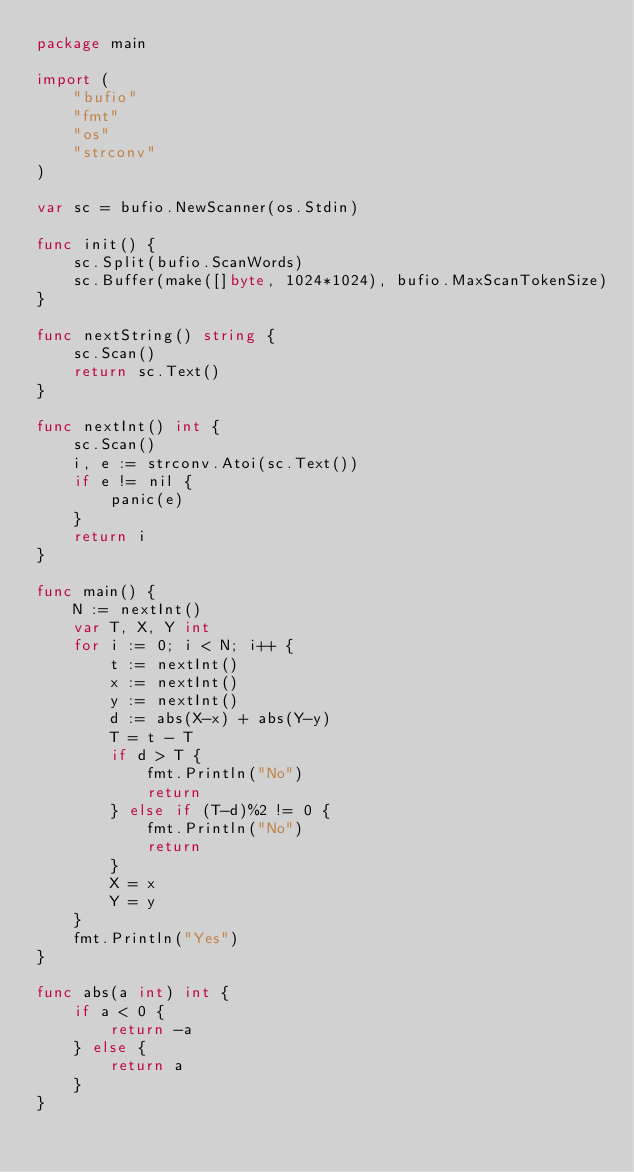<code> <loc_0><loc_0><loc_500><loc_500><_Go_>package main

import (
	"bufio"
	"fmt"
	"os"
	"strconv"
)

var sc = bufio.NewScanner(os.Stdin)

func init() {
	sc.Split(bufio.ScanWords)
	sc.Buffer(make([]byte, 1024*1024), bufio.MaxScanTokenSize)
}

func nextString() string {
	sc.Scan()
	return sc.Text()
}

func nextInt() int {
	sc.Scan()
	i, e := strconv.Atoi(sc.Text())
	if e != nil {
		panic(e)
	}
	return i
}

func main() {
	N := nextInt()
	var T, X, Y int
	for i := 0; i < N; i++ {
		t := nextInt()
		x := nextInt()
		y := nextInt()
		d := abs(X-x) + abs(Y-y)
		T = t - T
		if d > T {
			fmt.Println("No")
			return
		} else if (T-d)%2 != 0 {
			fmt.Println("No")
			return
		}
		X = x
		Y = y
	}
	fmt.Println("Yes")
}

func abs(a int) int {
	if a < 0 {
		return -a
	} else {
		return a
	}
}
</code> 